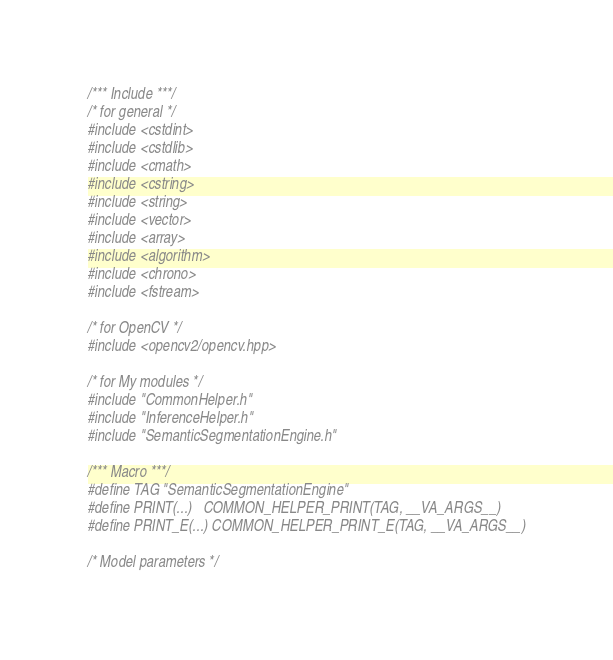Convert code to text. <code><loc_0><loc_0><loc_500><loc_500><_C++_>/*** Include ***/
/* for general */
#include <cstdint>
#include <cstdlib>
#include <cmath>
#include <cstring>
#include <string>
#include <vector>
#include <array>
#include <algorithm>
#include <chrono>
#include <fstream>

/* for OpenCV */
#include <opencv2/opencv.hpp>

/* for My modules */
#include "CommonHelper.h"
#include "InferenceHelper.h"
#include "SemanticSegmentationEngine.h"

/*** Macro ***/
#define TAG "SemanticSegmentationEngine"
#define PRINT(...)   COMMON_HELPER_PRINT(TAG, __VA_ARGS__)
#define PRINT_E(...) COMMON_HELPER_PRINT_E(TAG, __VA_ARGS__)

/* Model parameters */</code> 